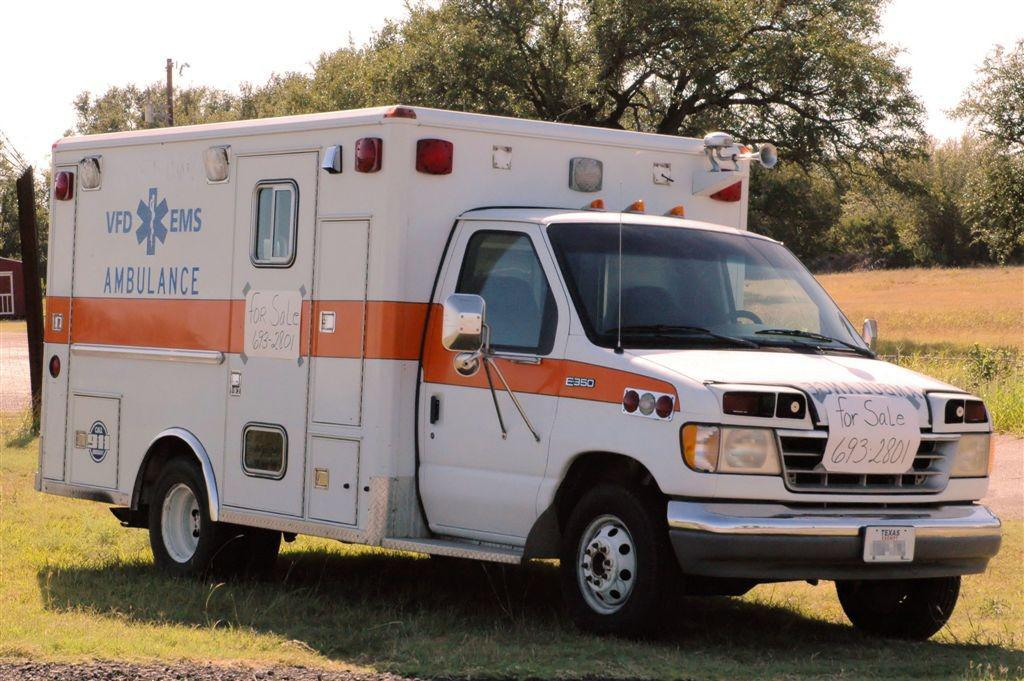Provide a one-sentence caption for the provided image. An ambulance is parked on a grass field. 